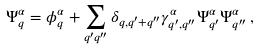Convert formula to latex. <formula><loc_0><loc_0><loc_500><loc_500>\Psi ^ { \alpha } _ { q } = \phi ^ { \alpha } _ { q } + \sum _ { q ^ { \prime } q ^ { \prime \prime } } \delta _ { q , q ^ { \prime } + q ^ { \prime \prime } } \gamma ^ { \alpha } _ { q ^ { \prime } , q ^ { \prime \prime } } \Psi ^ { \alpha } _ { q ^ { \prime } } \Psi ^ { \alpha } _ { q ^ { \prime \prime } } \, ,</formula> 